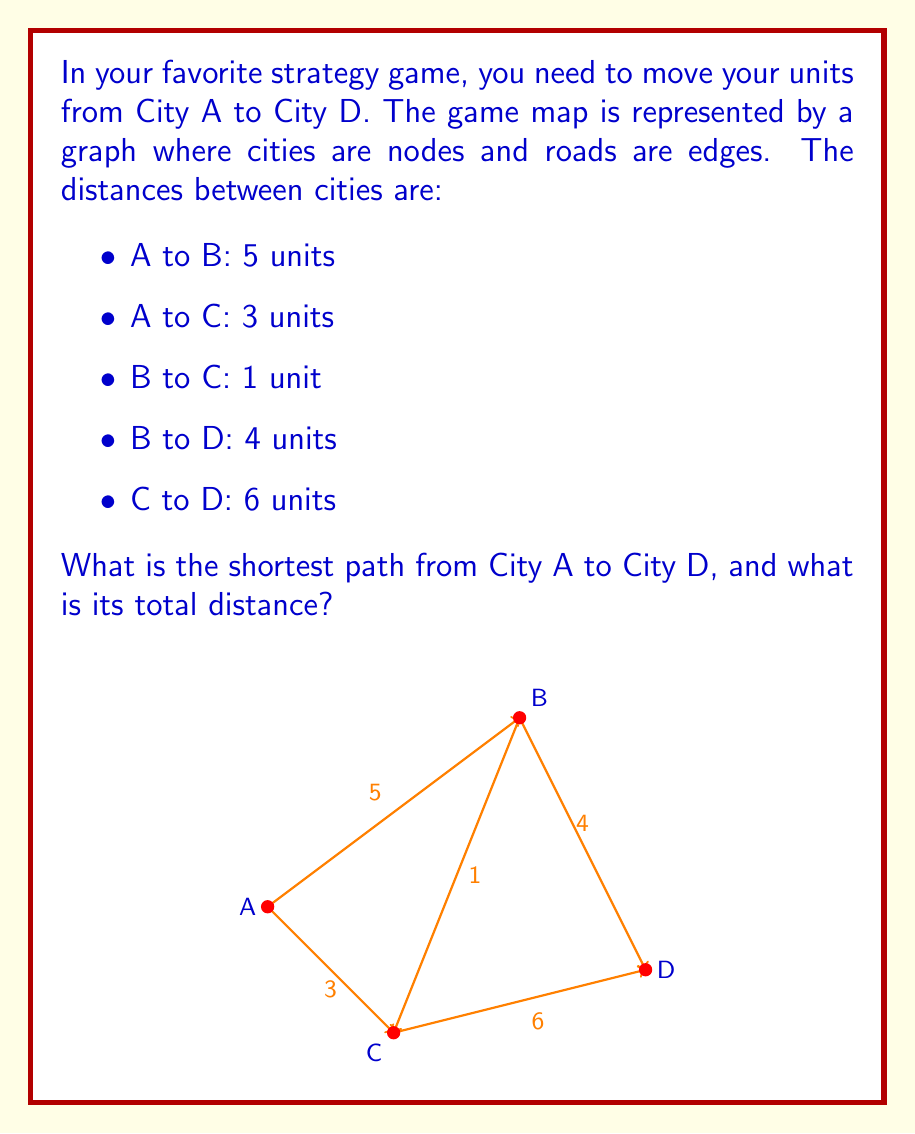Could you help me with this problem? To solve this problem, we can use Dijkstra's algorithm, which is an efficient method for finding the shortest path in a graph. Let's go through the steps:

1) Initialize:
   - Distance to A: 0
   - Distance to B, C, D: infinity

2) From A, we can reach:
   - B with distance 5
   - C with distance 3
   Update these distances.

3) The shortest unvisited node is C (distance 3). From C, we can reach:
   - B with distance 3 + 1 = 4 (shorter than current 5, so update)
   - D with distance 3 + 6 = 9

4) The next shortest unvisited node is B (distance 4). From B, we can reach:
   - D with distance 4 + 4 = 8 (shorter than current 9, so update)

5) The final node D has a shortest distance of 8.

The shortest path is therefore A → C → B → D, with a total distance of 8 units.

This problem demonstrates how graph theory can be applied to find optimal routes in strategy games, which is crucial for efficient unit movement and resource management.
Answer: The shortest path from City A to City D is A → C → B → D, with a total distance of 8 units. 